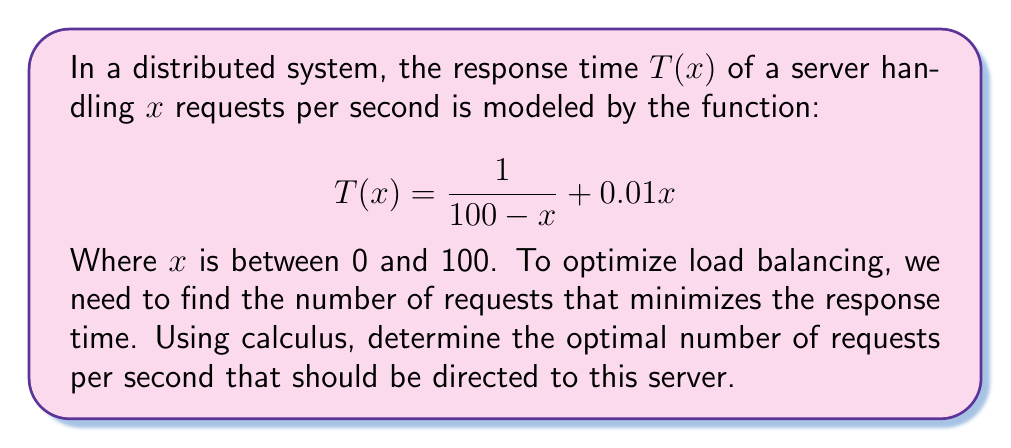Provide a solution to this math problem. To find the optimal number of requests, we need to minimize the response time function $T(x)$. This can be done by finding the value of $x$ where the derivative of $T(x)$ equals zero.

Step 1: Calculate the derivative of $T(x)$
$$T'(x) = \frac{d}{dx}\left(\frac{1}{100-x} + 0.01x\right)$$
$$T'(x) = \frac{1}{(100-x)^2} + 0.01$$

Step 2: Set the derivative equal to zero and solve for x
$$\frac{1}{(100-x)^2} + 0.01 = 0$$
$$\frac{1}{(100-x)^2} = -0.01$$
$$(100-x)^2 = 100$$
$$100-x = 10$$ (we take the positive root as x < 100)
$$x = 90$$

Step 3: Verify this is a minimum by checking the second derivative
$$T''(x) = \frac{2}{(100-x)^3}$$
At $x = 90$, $T''(90) = \frac{2}{1000} > 0$, confirming a minimum.

Therefore, the optimal number of requests per second to minimize response time is 90.
Answer: 90 requests per second 